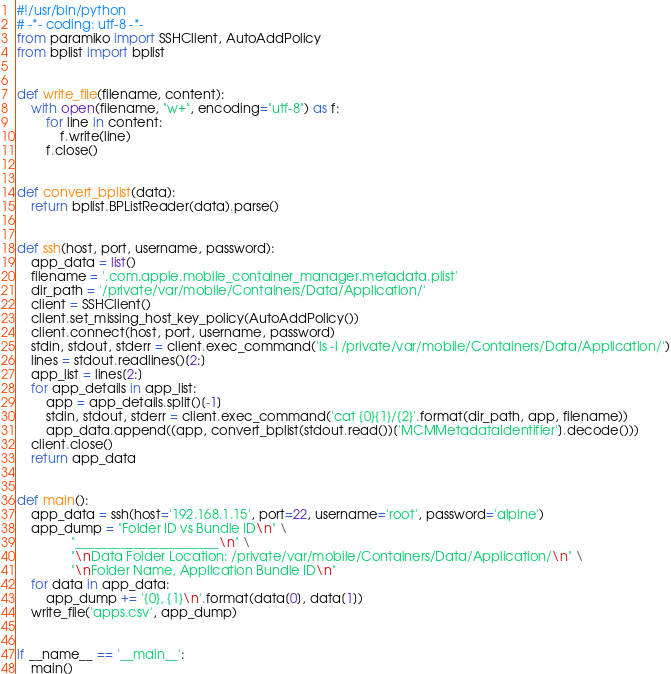<code> <loc_0><loc_0><loc_500><loc_500><_Python_>#!/usr/bin/python
# -*- coding: utf-8 -*-
from paramiko import SSHClient, AutoAddPolicy
from bplist import bplist


def write_file(filename, content):
    with open(filename, "w+", encoding="utf-8") as f:
        for line in content:
            f.write(line)
        f.close()


def convert_bplist(data):
    return bplist.BPListReader(data).parse()


def ssh(host, port, username, password):
    app_data = list()
    filename = '.com.apple.mobile_container_manager.metadata.plist'
    dir_path = '/private/var/mobile/Containers/Data/Application/'
    client = SSHClient()
    client.set_missing_host_key_policy(AutoAddPolicy())
    client.connect(host, port, username, password)
    stdin, stdout, stderr = client.exec_command('ls -l /private/var/mobile/Containers/Data/Application/')
    lines = stdout.readlines()[2:]
    app_list = lines[2:]
    for app_details in app_list:
        app = app_details.split()[-1]
        stdin, stdout, stderr = client.exec_command('cat {0}{1}/{2}'.format(dir_path, app, filename))
        app_data.append((app, convert_bplist(stdout.read())['MCMMetadataIdentifier'].decode()))
    client.close()
    return app_data


def main():
    app_data = ssh(host='192.168.1.15', port=22, username='root', password='alpine')
    app_dump = "Folder ID vs Bundle ID\n" \
               "______________________\n" \
               "\nData Folder Location: /private/var/mobile/Containers/Data/Application/\n" \
               "\nFolder Name, Application Bundle ID\n"
    for data in app_data:
        app_dump += '{0}, {1}\n'.format(data[0], data[1])
    write_file('apps.csv', app_dump)


if __name__ == '__main__':
    main()
</code> 